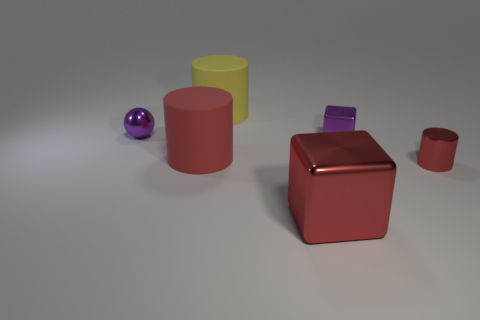There is a big red object that is the same shape as the large yellow rubber thing; what is its material?
Offer a very short reply. Rubber. There is a object in front of the tiny red object; is its color the same as the big matte object that is behind the big red rubber cylinder?
Your answer should be very brief. No. Are there any red things that have the same size as the metal cylinder?
Your response must be concise. No. There is a small object that is both behind the tiny red shiny cylinder and in front of the metal sphere; what is its material?
Provide a short and direct response. Metal. How many metal things are either gray objects or tiny spheres?
Your answer should be very brief. 1. There is a large object that is the same material as the tiny red thing; what is its shape?
Make the answer very short. Cube. How many objects are right of the ball and on the left side of the large yellow rubber object?
Ensure brevity in your answer.  1. Are there any other things that have the same shape as the large yellow matte thing?
Make the answer very short. Yes. There is a cylinder behind the purple shiny sphere; what is its size?
Your response must be concise. Large. What number of other objects are the same color as the large block?
Provide a short and direct response. 2. 